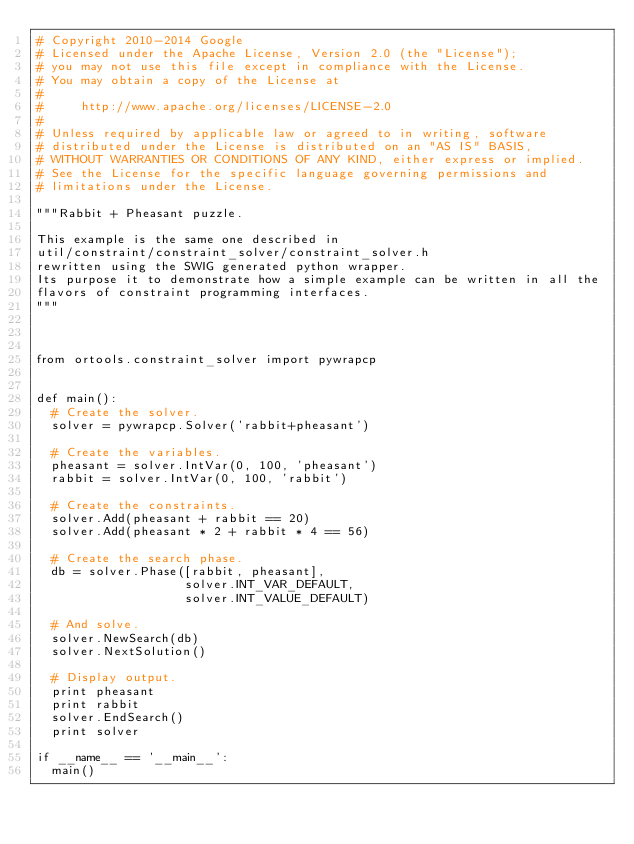Convert code to text. <code><loc_0><loc_0><loc_500><loc_500><_Python_># Copyright 2010-2014 Google
# Licensed under the Apache License, Version 2.0 (the "License");
# you may not use this file except in compliance with the License.
# You may obtain a copy of the License at
#
#     http://www.apache.org/licenses/LICENSE-2.0
#
# Unless required by applicable law or agreed to in writing, software
# distributed under the License is distributed on an "AS IS" BASIS,
# WITHOUT WARRANTIES OR CONDITIONS OF ANY KIND, either express or implied.
# See the License for the specific language governing permissions and
# limitations under the License.

"""Rabbit + Pheasant puzzle.

This example is the same one described in
util/constraint/constraint_solver/constraint_solver.h
rewritten using the SWIG generated python wrapper.
Its purpose it to demonstrate how a simple example can be written in all the
flavors of constraint programming interfaces.
"""



from ortools.constraint_solver import pywrapcp


def main():
  # Create the solver.
  solver = pywrapcp.Solver('rabbit+pheasant')

  # Create the variables.
  pheasant = solver.IntVar(0, 100, 'pheasant')
  rabbit = solver.IntVar(0, 100, 'rabbit')

  # Create the constraints.
  solver.Add(pheasant + rabbit == 20)
  solver.Add(pheasant * 2 + rabbit * 4 == 56)

  # Create the search phase.
  db = solver.Phase([rabbit, pheasant],
                    solver.INT_VAR_DEFAULT,
                    solver.INT_VALUE_DEFAULT)

  # And solve.
  solver.NewSearch(db)
  solver.NextSolution()

  # Display output.
  print pheasant
  print rabbit
  solver.EndSearch()
  print solver

if __name__ == '__main__':
  main()
</code> 